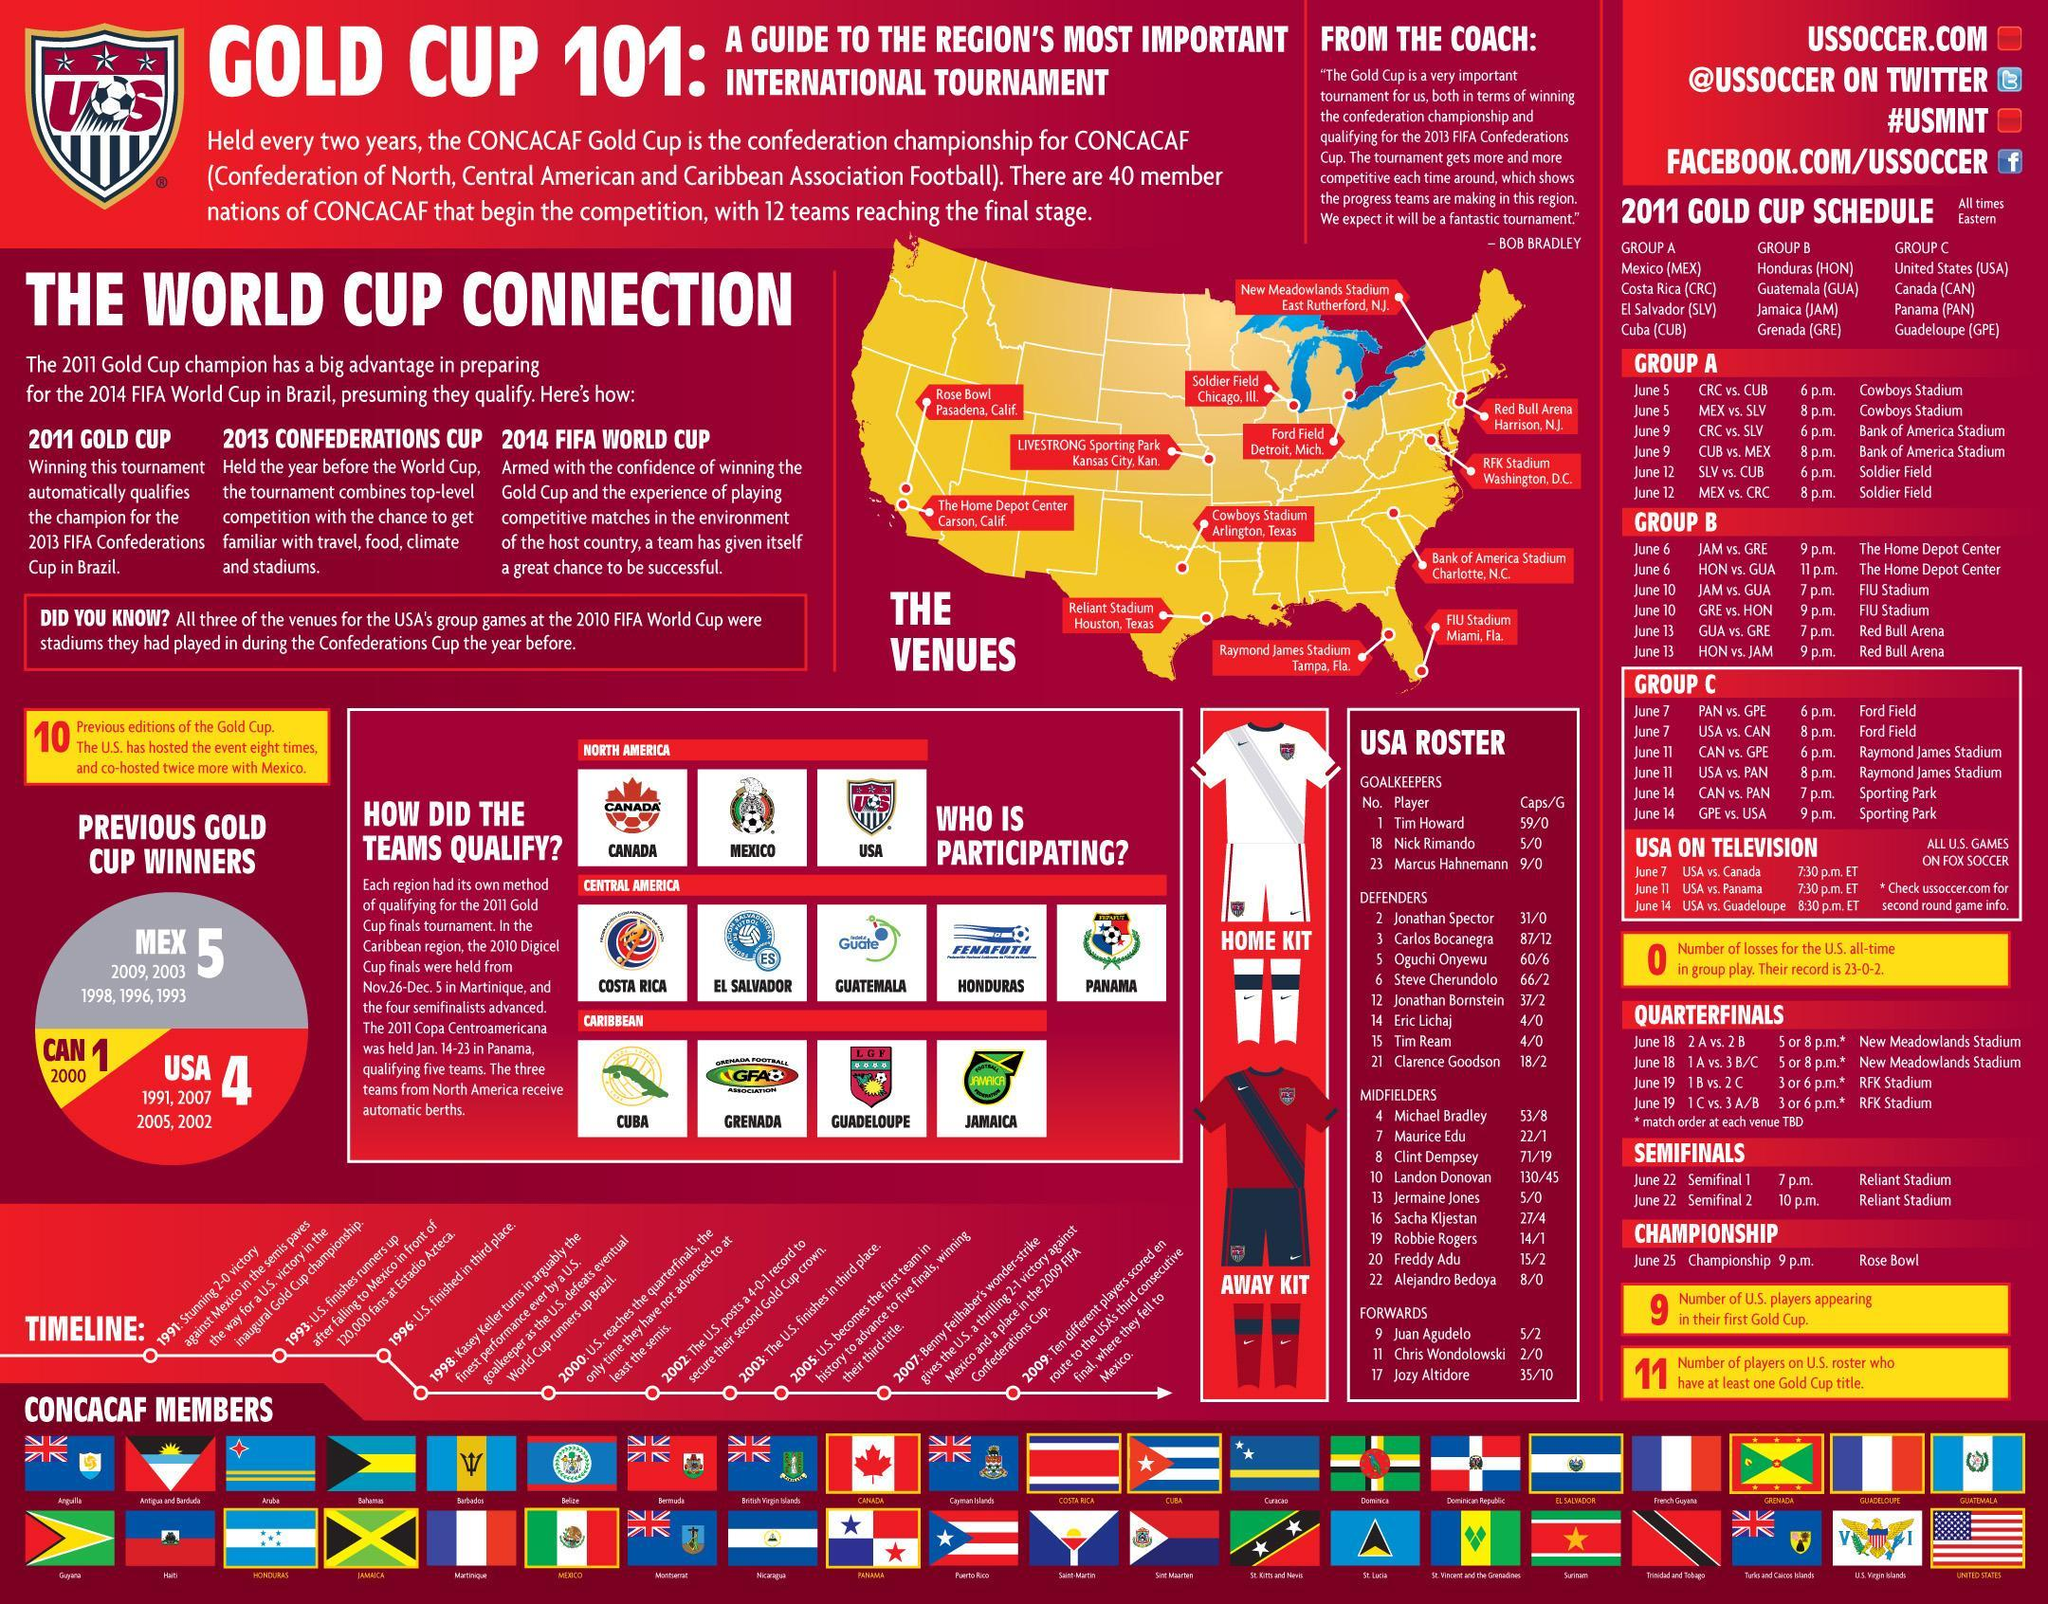How many CONCACAF Members are shown?
Answer the question with a short phrase. 40 